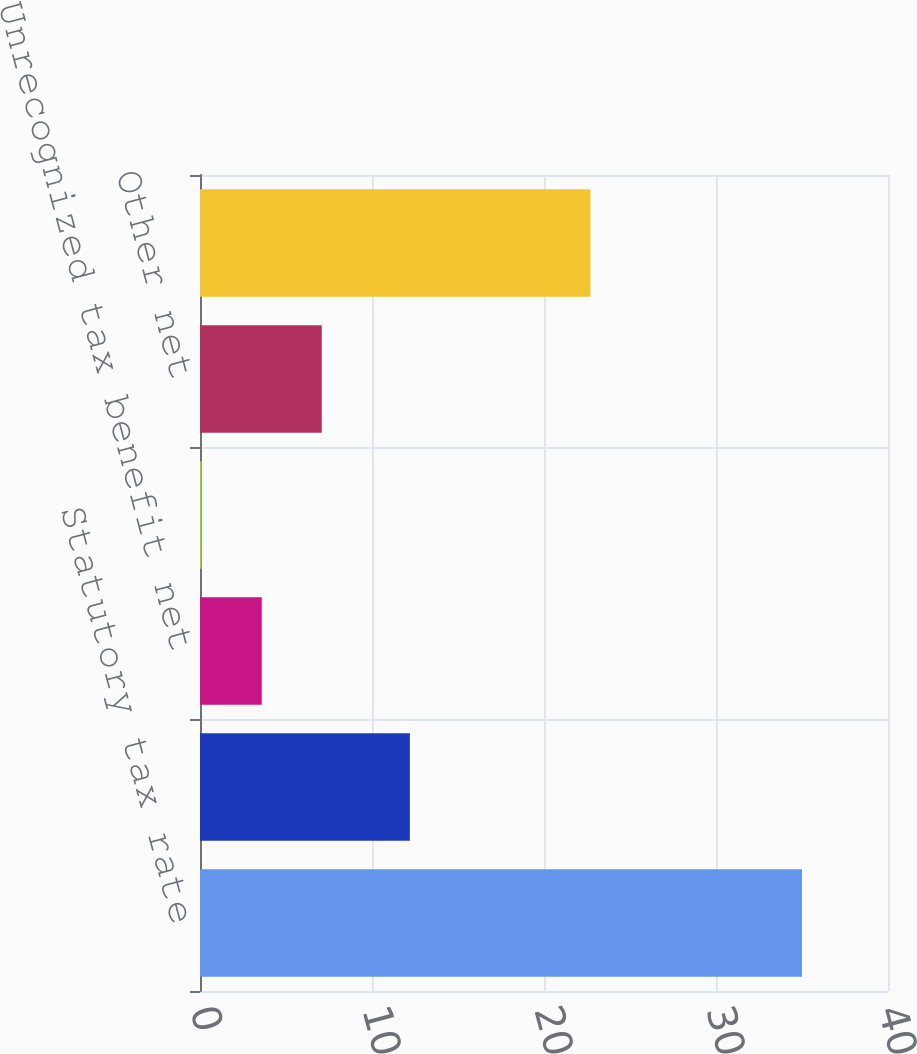Convert chart. <chart><loc_0><loc_0><loc_500><loc_500><bar_chart><fcel>Statutory tax rate<fcel>Difference in effective tax<fcel>Unrecognized tax benefit net<fcel>State and local taxes<fcel>Other net<fcel>Effective tax rate<nl><fcel>35<fcel>12.2<fcel>3.59<fcel>0.1<fcel>7.08<fcel>22.7<nl></chart> 